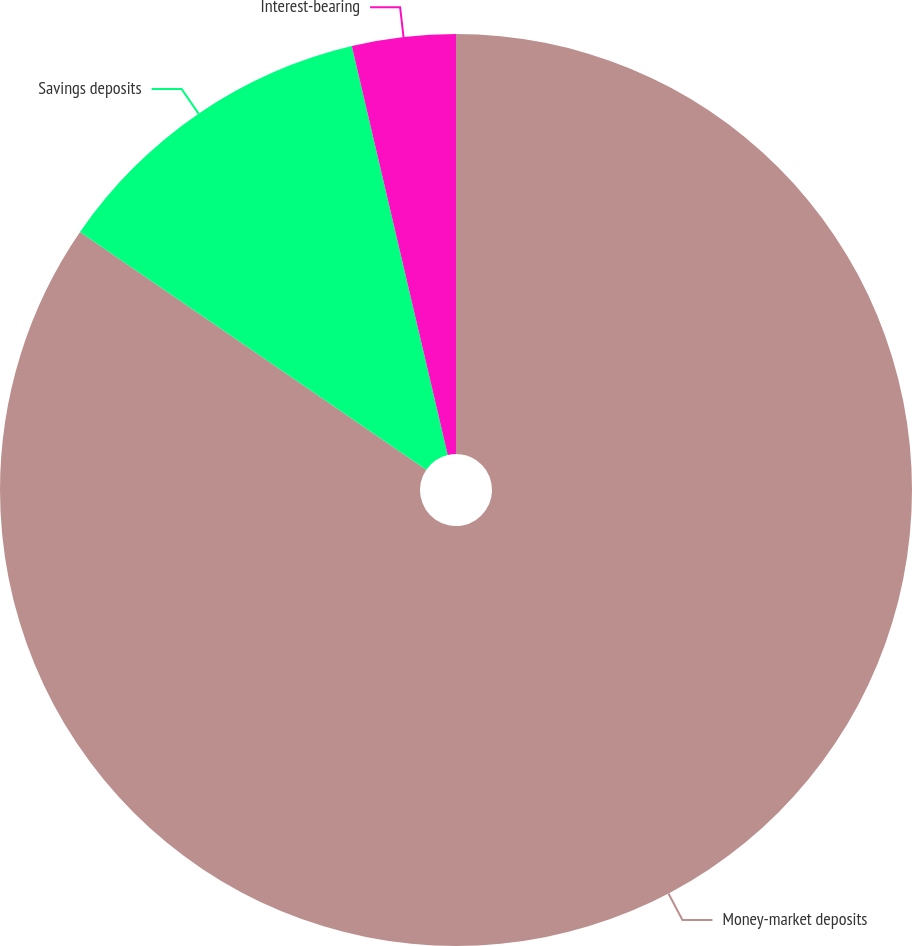Convert chart. <chart><loc_0><loc_0><loc_500><loc_500><pie_chart><fcel>Money-market deposits<fcel>Savings deposits<fcel>Interest-bearing<nl><fcel>84.58%<fcel>11.76%<fcel>3.67%<nl></chart> 